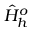<formula> <loc_0><loc_0><loc_500><loc_500>\hat { H } _ { h } ^ { o }</formula> 